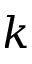Convert formula to latex. <formula><loc_0><loc_0><loc_500><loc_500>k</formula> 